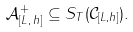Convert formula to latex. <formula><loc_0><loc_0><loc_500><loc_500>\mathcal { A } ^ { + } _ { [ L , \, h ] } \subseteq S _ { T } ( \mathcal { C } _ { [ L , h ] } ) .</formula> 